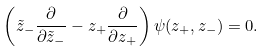<formula> <loc_0><loc_0><loc_500><loc_500>\left ( \tilde { z } _ { - } \frac { \partial } { \partial \tilde { z } _ { - } } - z _ { + } \frac { \partial } { \partial z _ { + } } \right ) \psi ( z _ { + } , z _ { - } ) = 0 .</formula> 